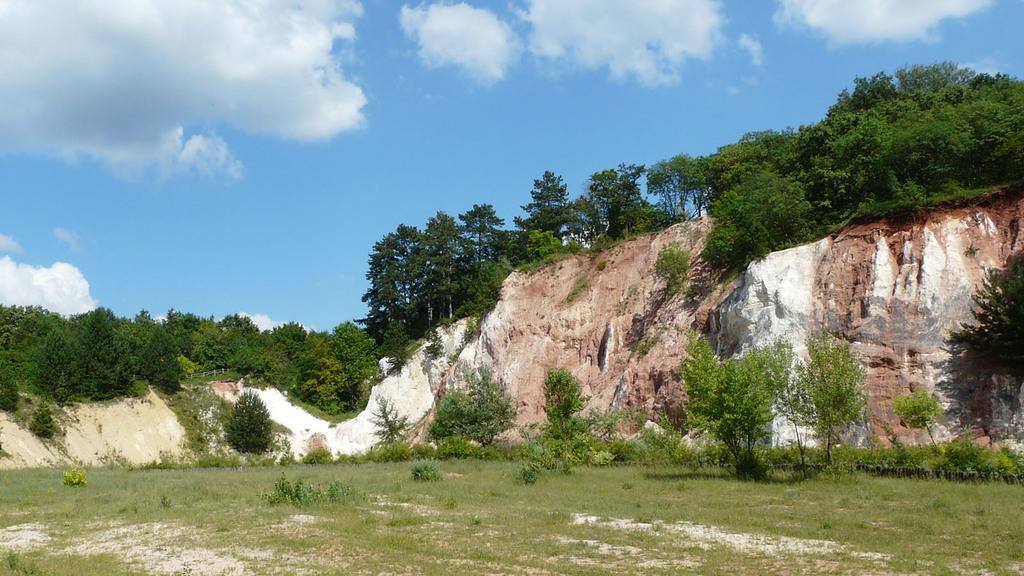Please provide a concise description of this image. There is a land covered with a lot of grass and small plants and behind that there is a hill around the grass and on the hill there are plenty of trees. 